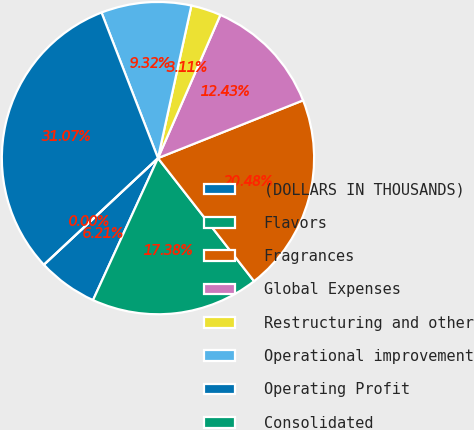<chart> <loc_0><loc_0><loc_500><loc_500><pie_chart><fcel>(DOLLARS IN THOUSANDS)<fcel>Flavors<fcel>Fragrances<fcel>Global Expenses<fcel>Restructuring and other<fcel>Operational improvement<fcel>Operating Profit<fcel>Consolidated<nl><fcel>6.21%<fcel>17.38%<fcel>20.48%<fcel>12.43%<fcel>3.11%<fcel>9.32%<fcel>31.07%<fcel>0.0%<nl></chart> 